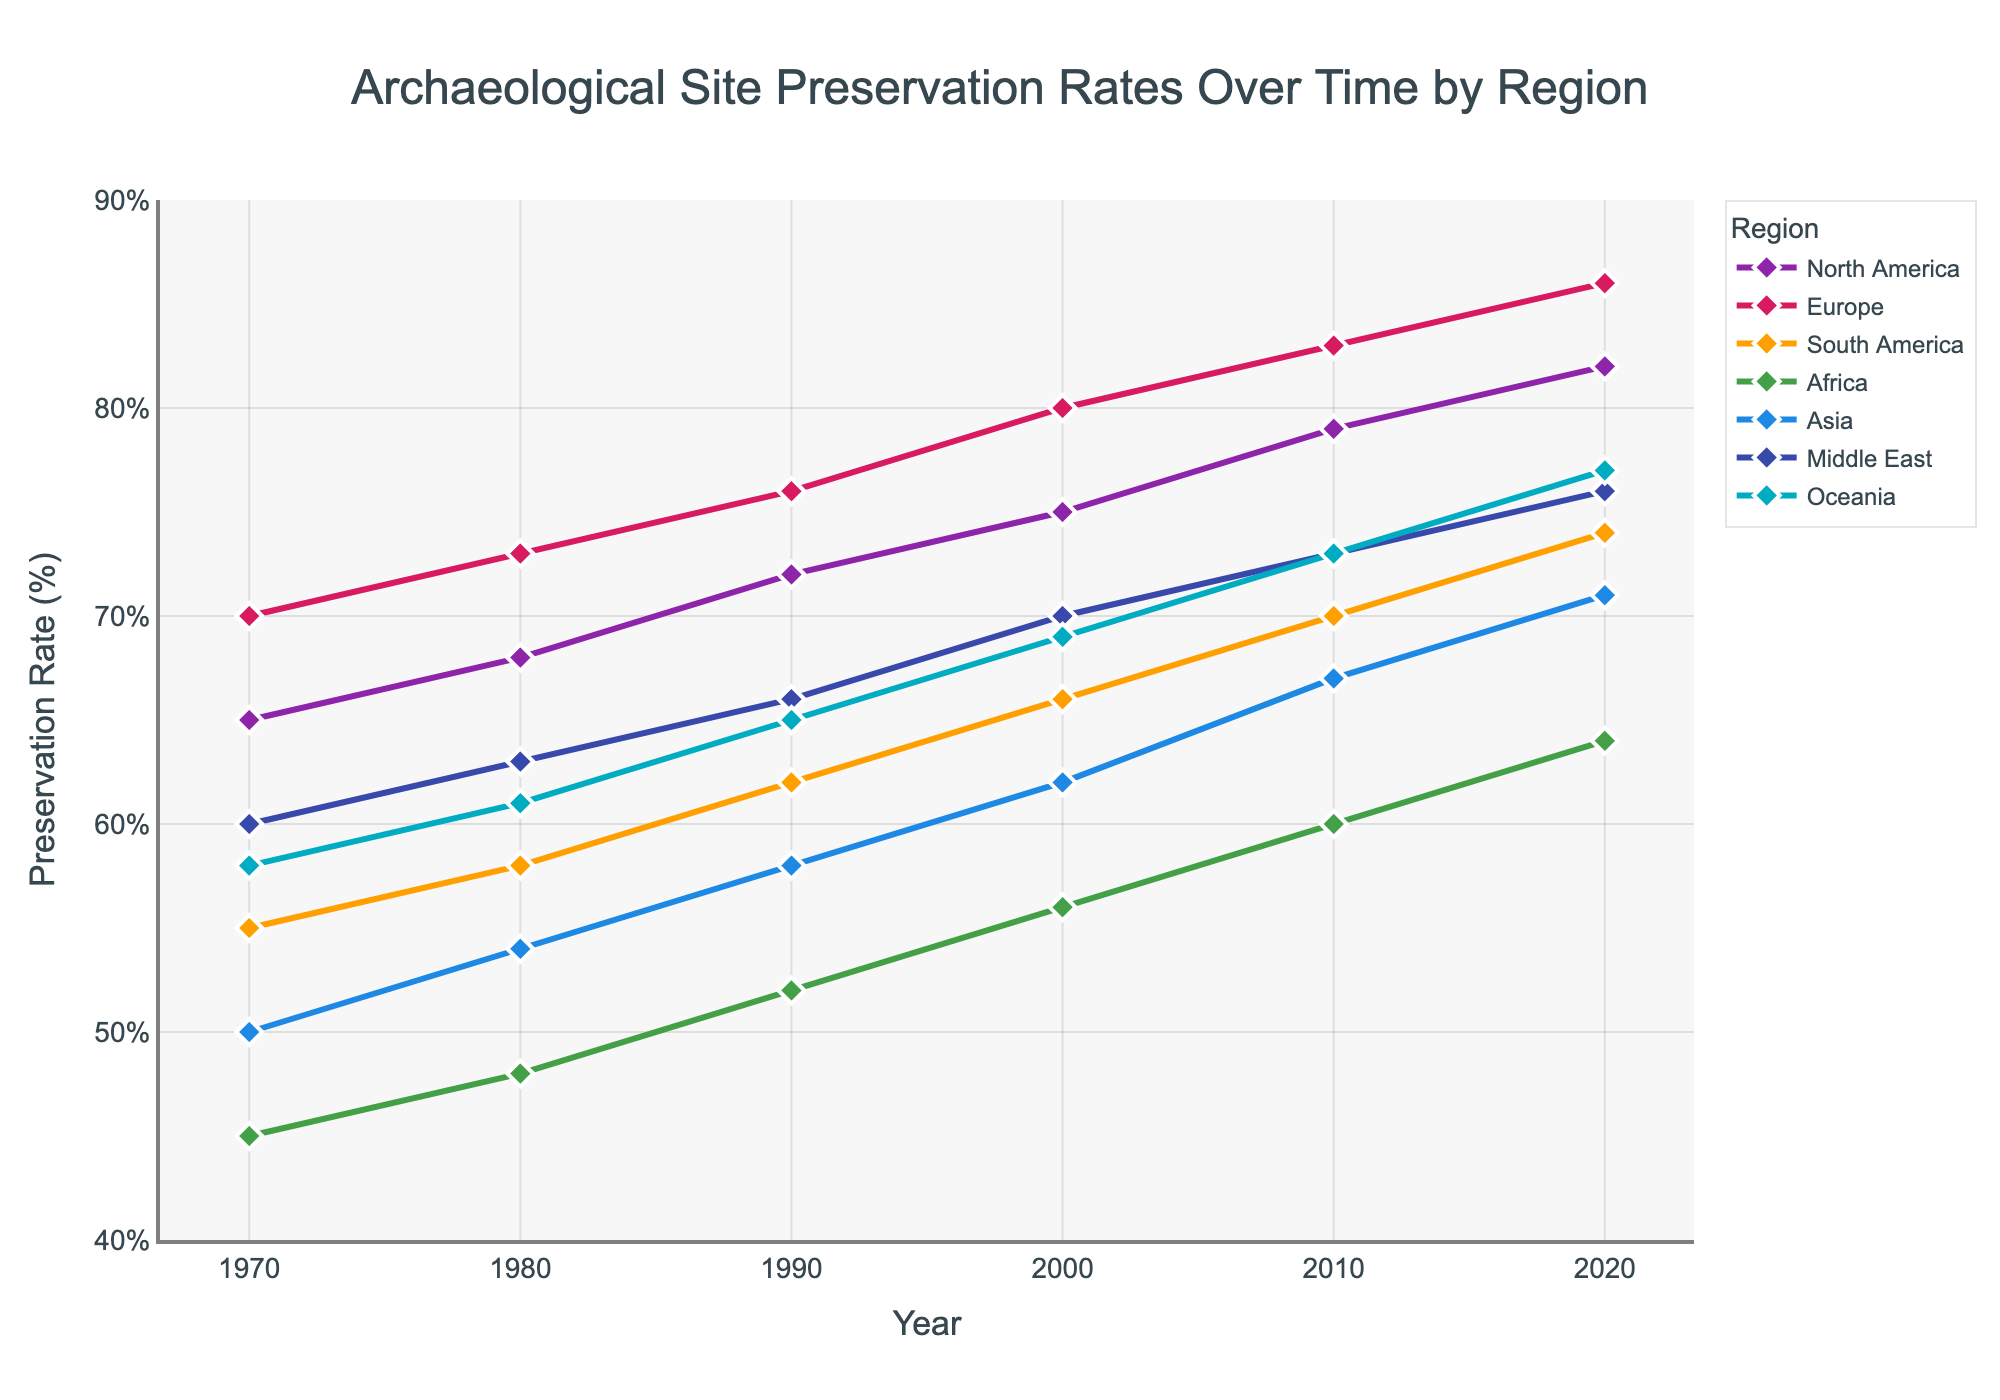what's the region with the highest preservation rate in 2020? In 2020, the highest line on the chart corresponds to the region with the highest preservation rate. Follow the lines to see the corresponding value for 2020. Europe reaches 86%, which is the highest.
Answer: Europe Which region shows the greatest increase in preservation rate from 1970 to 2020? To determine the greatest increase, subtract the 1970 value from the 2020 value for each region and compare the results. Europe: 86-70=16, North America: 82-65=17, South America: 74-55=19, Africa: 64-45=19, Asia: 71-50=21, Middle East: 76-60=16, Oceania: 77-58=19. Asia shows the greatest increase with 21.
Answer: Asia What is the overall trend of archaeological site preservation rates in Africa? Follow the line representing Africa over the years. The line consistently rises from 45% in 1970 to 64% in 2020, indicating a steady increase over time.
Answer: Steady increase Which two regions have the closest preservation rates in 2010? Look at the 2010 marks for each region and find the two with the closest values. Africa is at 60%, Oceania is at 73%, Asia is at 67%, Middle East is at 73%, Europe is at 83%, North America is at 79%, and South America is at 70%. Oceania and Middle East both have 73%.
Answer: Oceania and Middle East Compare Europe and North America's preservation rates throughout the decades. Which one generally had higher rates? Compare the lines of Europe and North America at each decade's marker. For each decade, Europe has higher values: 1970 (70 vs 65), 1980 (73 vs 68), 1990 (76 vs 72), 2000 (80 vs 75), 2010 (83 vs 79), 2020 (86 vs 82). Europe consistently had higher rates.
Answer: Europe What is the median preservation rate value for Asia across the decades? Find the preservation rates for Asia in each decade and arrange them: 50 (1970), 54 (1980), 58 (1990), 62 (2000), 67 (2010), 71 (2020). The median value in an ordered set of 6 elements is the average of the 3rd and 4th values: (58 + 62)/2 = 60.
Answer: 60 How much did Oceania's preservation rate increase from 1980 to 2020? Subtract the 1980 value from the 2020 value for Oceania. Oceania’s rate in 1980 is 61%, and in 2020 it is 77%, so the increase is 77 - 61 = 16.
Answer: 16 Which region had the lowest preservation rate in 1970 and what was the value? Look at the 1970 markers for each region. Africa has the lowest at 45%.
Answer: Africa, 45 If you average the preservation rate of all regions in 2020, what would it be? Sum all 2020 values and divide by the number of regions. (82 + 86 + 74 + 64 + 71 + 76 + 77) / 7 = 530 / 7 = 75.7.
Answer: 75.7 